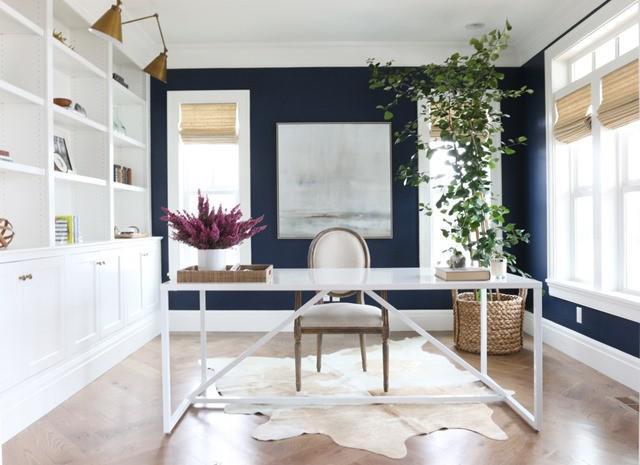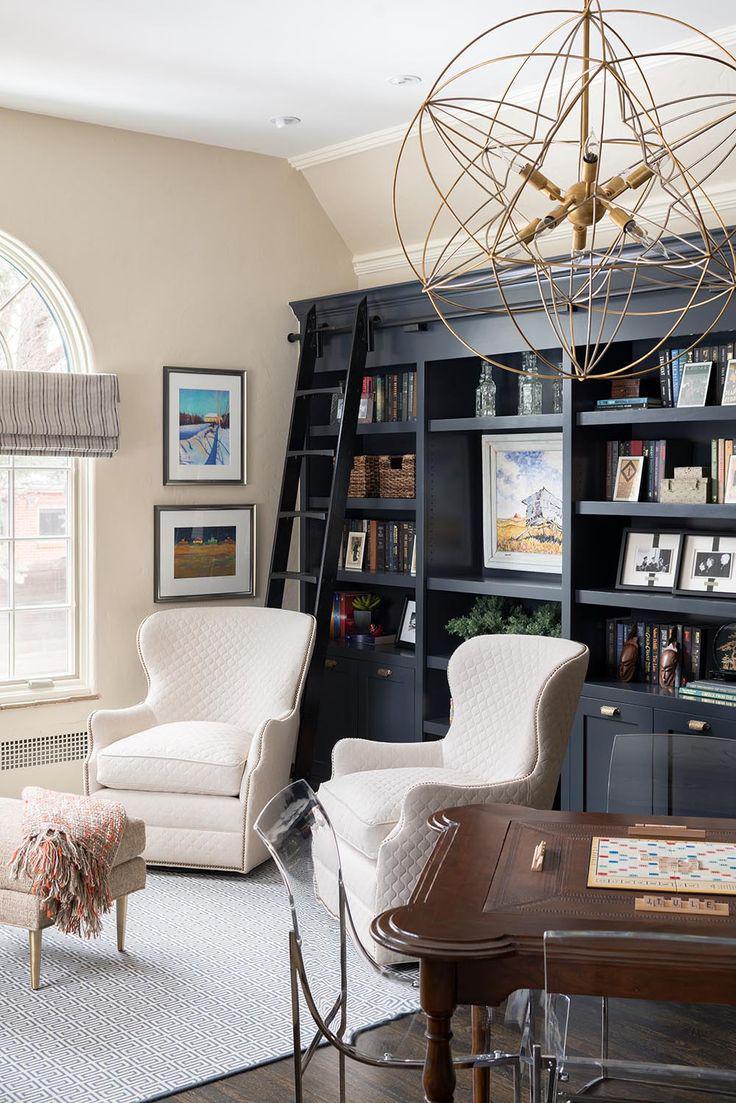The first image is the image on the left, the second image is the image on the right. Assess this claim about the two images: "In one image, a large white shelving unit has solid panel doors at the bottom, open shelves at the top, and a television in the center position.". Correct or not? Answer yes or no. No. The first image is the image on the left, the second image is the image on the right. Assess this claim about the two images: "A room with a built-in bookcase also features a 'gravity defying' item of decor utilizing negative space.". Correct or not? Answer yes or no. Yes. 